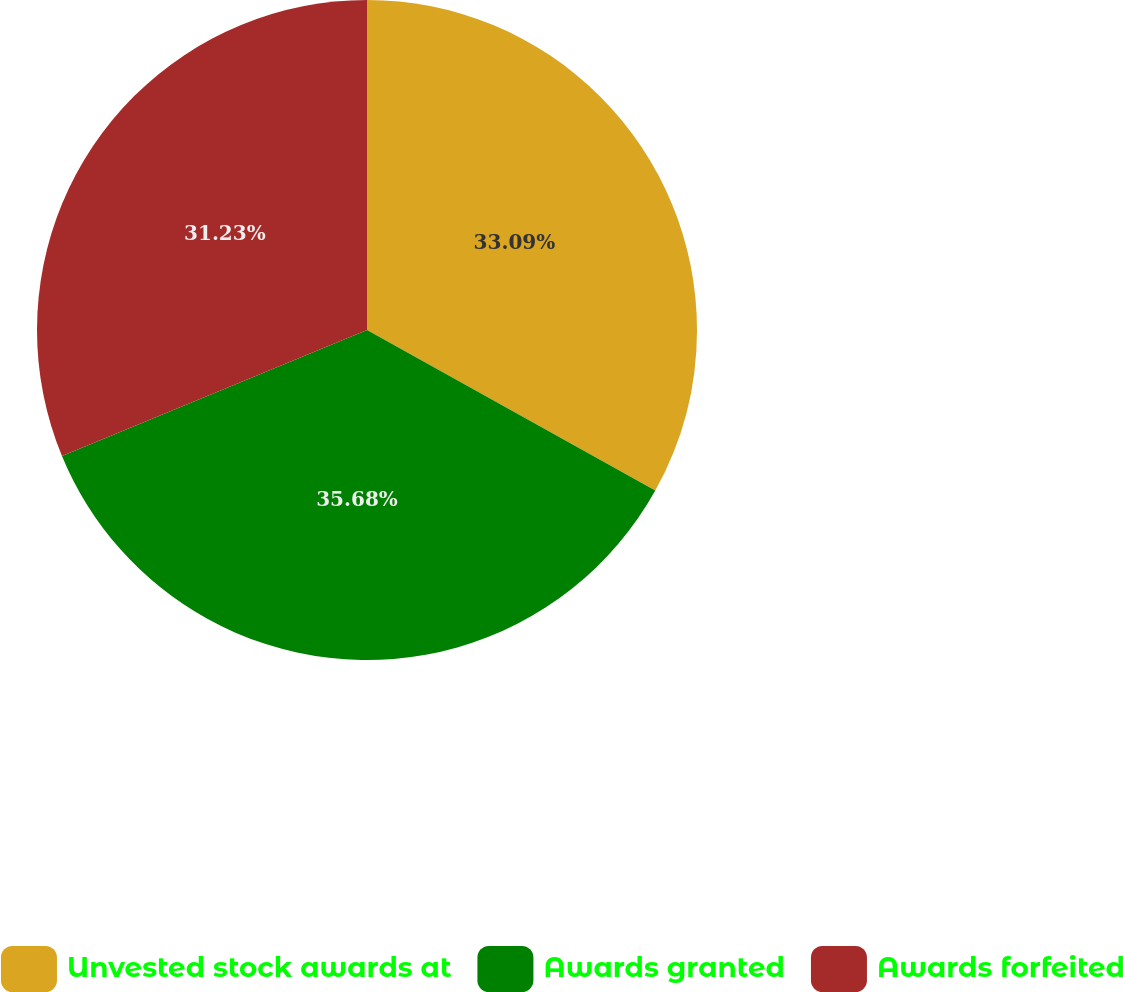<chart> <loc_0><loc_0><loc_500><loc_500><pie_chart><fcel>Unvested stock awards at<fcel>Awards granted<fcel>Awards forfeited<nl><fcel>33.09%<fcel>35.68%<fcel>31.23%<nl></chart> 